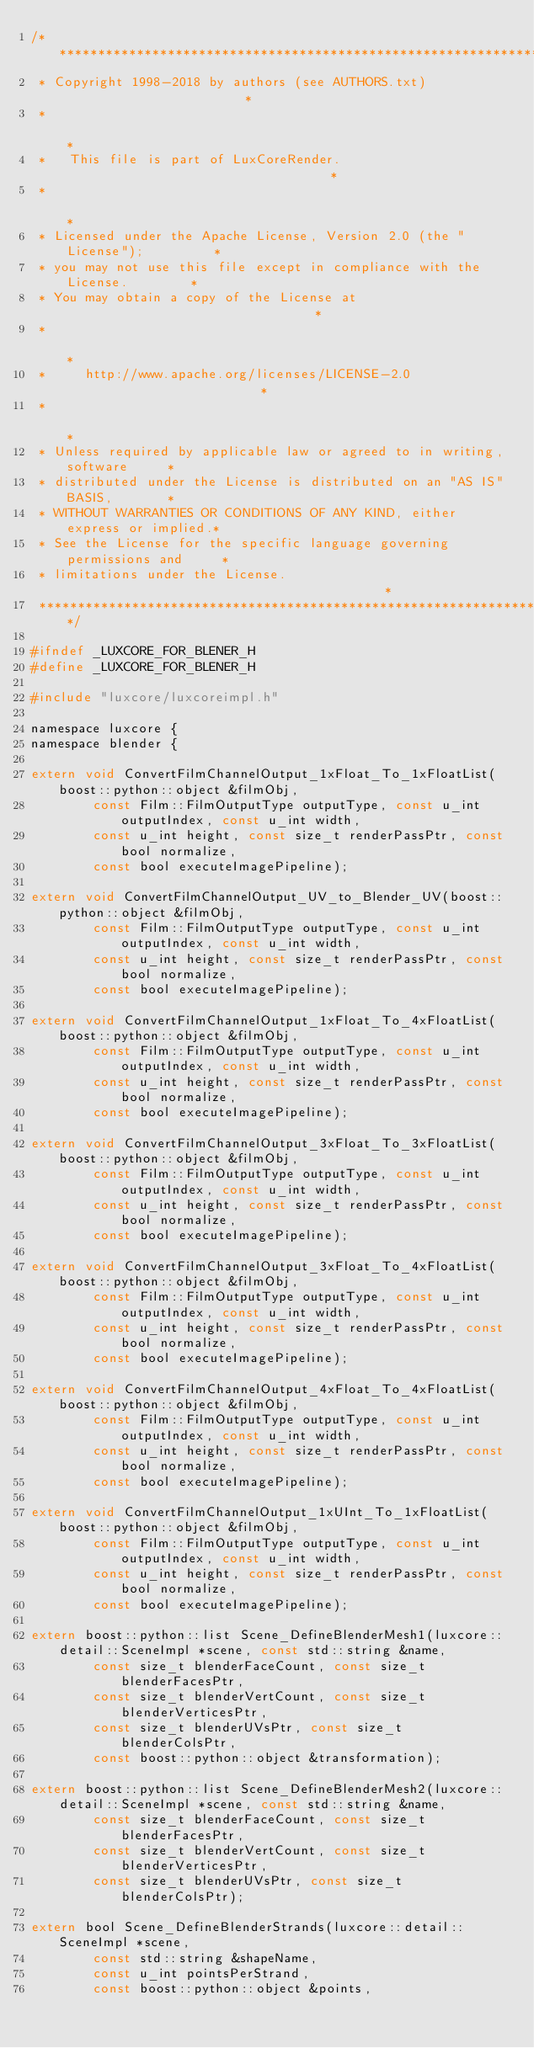Convert code to text. <code><loc_0><loc_0><loc_500><loc_500><_C_>/***************************************************************************
 * Copyright 1998-2018 by authors (see AUTHORS.txt)                        *
 *                                                                         *
 *   This file is part of LuxCoreRender.                                   *
 *                                                                         *
 * Licensed under the Apache License, Version 2.0 (the "License");         *
 * you may not use this file except in compliance with the License.        *
 * You may obtain a copy of the License at                                 *
 *                                                                         *
 *     http://www.apache.org/licenses/LICENSE-2.0                          *
 *                                                                         *
 * Unless required by applicable law or agreed to in writing, software     *
 * distributed under the License is distributed on an "AS IS" BASIS,       *
 * WITHOUT WARRANTIES OR CONDITIONS OF ANY KIND, either express or implied.*
 * See the License for the specific language governing permissions and     *
 * limitations under the License.                                          *
 ***************************************************************************/

#ifndef _LUXCORE_FOR_BLENER_H
#define	_LUXCORE_FOR_BLENER_H

#include "luxcore/luxcoreimpl.h"

namespace luxcore {
namespace blender {

extern void ConvertFilmChannelOutput_1xFloat_To_1xFloatList(boost::python::object &filmObj,
		const Film::FilmOutputType outputType, const u_int outputIndex, const u_int width,
		const u_int height, const size_t renderPassPtr, const bool normalize,
		const bool executeImagePipeline);
		
extern void ConvertFilmChannelOutput_UV_to_Blender_UV(boost::python::object &filmObj,
		const Film::FilmOutputType outputType, const u_int outputIndex, const u_int width,
		const u_int height, const size_t renderPassPtr, const bool normalize,
		const bool executeImagePipeline);
		
extern void ConvertFilmChannelOutput_1xFloat_To_4xFloatList(boost::python::object &filmObj,
		const Film::FilmOutputType outputType, const u_int outputIndex, const u_int width,
		const u_int height, const size_t renderPassPtr, const bool normalize,
		const bool executeImagePipeline);
		
extern void ConvertFilmChannelOutput_3xFloat_To_3xFloatList(boost::python::object &filmObj,
		const Film::FilmOutputType outputType, const u_int outputIndex, const u_int width,
		const u_int height, const size_t renderPassPtr, const bool normalize,
		const bool executeImagePipeline);
		
extern void ConvertFilmChannelOutput_3xFloat_To_4xFloatList(boost::python::object &filmObj,
		const Film::FilmOutputType outputType, const u_int outputIndex, const u_int width,
		const u_int height, const size_t renderPassPtr, const bool normalize,
		const bool executeImagePipeline);
		
extern void ConvertFilmChannelOutput_4xFloat_To_4xFloatList(boost::python::object &filmObj,
		const Film::FilmOutputType outputType, const u_int outputIndex, const u_int width,
		const u_int height, const size_t renderPassPtr, const bool normalize,
		const bool executeImagePipeline);
		
extern void ConvertFilmChannelOutput_1xUInt_To_1xFloatList(boost::python::object &filmObj,
		const Film::FilmOutputType outputType, const u_int outputIndex, const u_int width,
		const u_int height, const size_t renderPassPtr, const bool normalize,
		const bool executeImagePipeline);

extern boost::python::list Scene_DefineBlenderMesh1(luxcore::detail::SceneImpl *scene, const std::string &name,
		const size_t blenderFaceCount, const size_t blenderFacesPtr,
		const size_t blenderVertCount, const size_t blenderVerticesPtr,
		const size_t blenderUVsPtr, const size_t blenderColsPtr,
		const boost::python::object &transformation);
		
extern boost::python::list Scene_DefineBlenderMesh2(luxcore::detail::SceneImpl *scene, const std::string &name,
		const size_t blenderFaceCount, const size_t blenderFacesPtr,
		const size_t blenderVertCount, const size_t blenderVerticesPtr,
		const size_t blenderUVsPtr, const size_t blenderColsPtr);

extern bool Scene_DefineBlenderStrands(luxcore::detail::SceneImpl *scene,
		const std::string &shapeName,
		const u_int pointsPerStrand,
		const boost::python::object &points,</code> 